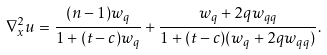Convert formula to latex. <formula><loc_0><loc_0><loc_500><loc_500>\nabla ^ { 2 } _ { x } u = \frac { ( n - 1 ) w _ { q } } { 1 + ( t - c ) w _ { q } } + \frac { w _ { q } + 2 q w _ { q q } } { 1 + ( t - c ) ( w _ { q } + 2 q w _ { q q } ) } .</formula> 